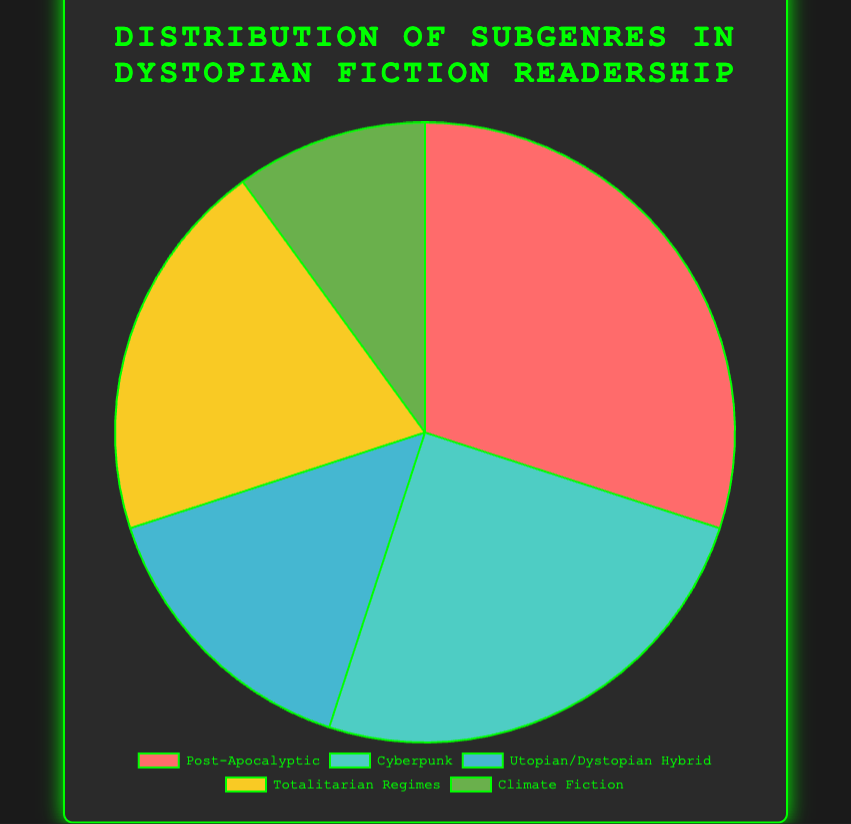What's the percentage of readership for the Cyberpunk subgenre? The Cyberpunk subgenre has a readership percentage listed in the pie chart. Look at the section labeled "Cyberpunk".
Answer: 25% Which subgenre has the highest readership percentage? Examine the slices of the pie chart and identify the one with the largest section. The Post-Apocalyptic section is the largest.
Answer: Post-Apocalyptic What is the difference in readership percentage between Totalitarian Regimes and Utopian/Dystopian Hybrid subgenres? The Totalitarian Regimes subgenre has a readership of 20%, and the Utopian/Dystopian Hybrid subgenre has 15%. The difference is calculated as 20% - 15%.
Answer: 5% Which section of the pie chart is represented by the color green? Look for the section of the pie chart filled with green color. The green color represents Climate Fiction.
Answer: Climate Fiction What is the total percentage of readership for the top two subgenres combined? The top two subgenres by readership are Post-Apocalyptic (30%) and Cyberpunk (25%). Adding these gives 30% + 25%.
Answer: 55% Is the readership percentage for Totalitarian Regimes greater than Climate Fiction but less than Cyberpunk? Totalitarian Regimes has a readership of 20%. Compare this with Climate Fiction (10%) and Cyberpunk (25%) to see if 20% lies between these two values.
Answer: Yes What's the combined readership percentage for the least popular two subgenres? The least popular subgenres are Utopian/Dystopian Hybrid (15%) and Climate Fiction (10%). Adding these gives 15% + 10%.
Answer: 25% Which subgenre has a readership percentage that is double that of Climate Fiction? Climate Fiction has 10% readership. Double this value is 20%. The subgenre with 20% readership is Totalitarian Regimes.
Answer: Totalitarian Regimes How much more popular is the Post-Apocalyptic subgenre compared to Climate Fiction? Post-Apocalyptic has 30% readership, and Climate Fiction has 10%. The difference is 30% - 10%.
Answer: 20% 